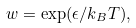Convert formula to latex. <formula><loc_0><loc_0><loc_500><loc_500>w = \exp ( \epsilon / k _ { B } T ) ,</formula> 